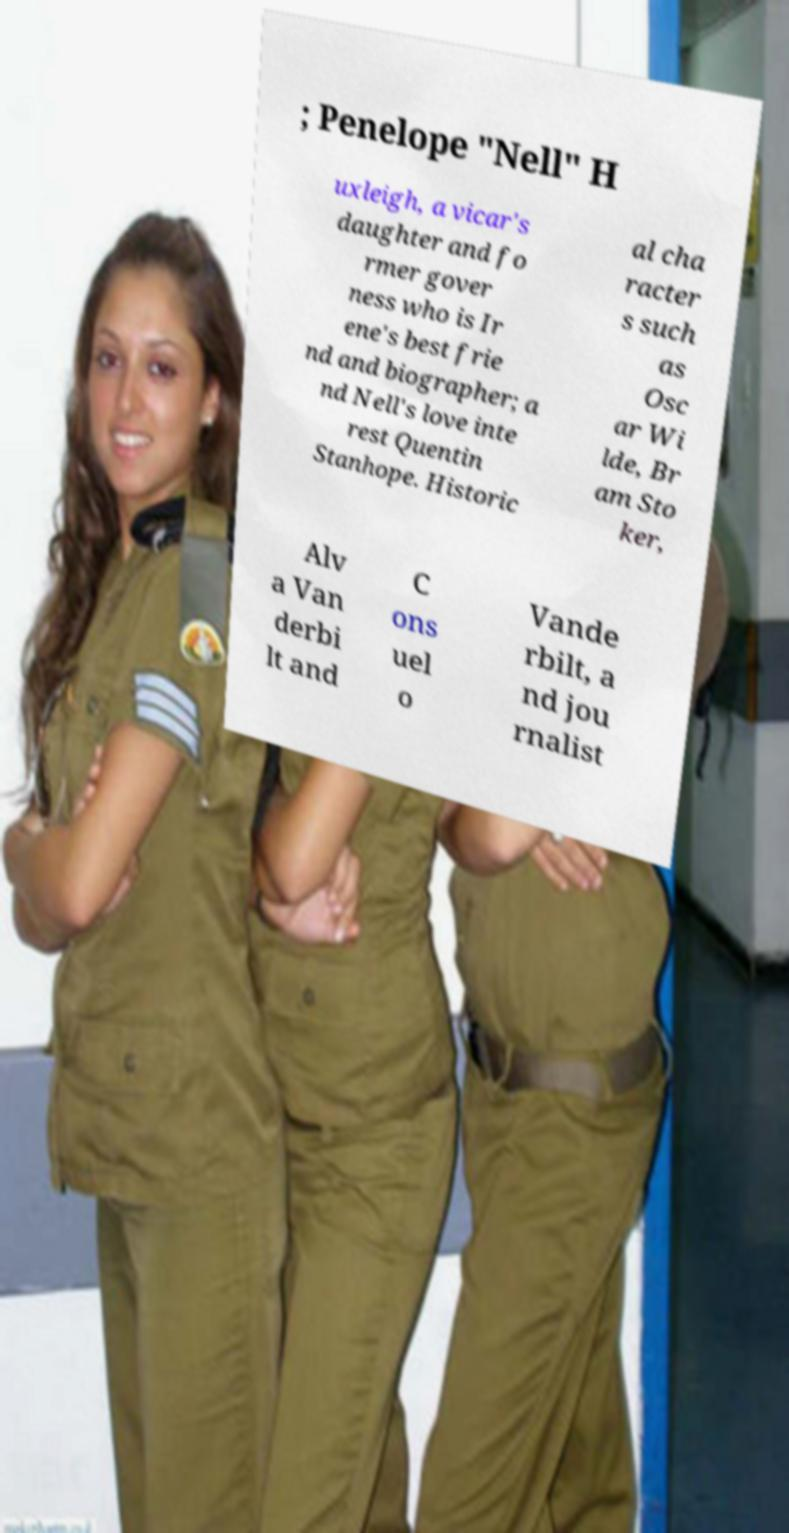Please identify and transcribe the text found in this image. ; Penelope "Nell" H uxleigh, a vicar's daughter and fo rmer gover ness who is Ir ene's best frie nd and biographer; a nd Nell's love inte rest Quentin Stanhope. Historic al cha racter s such as Osc ar Wi lde, Br am Sto ker, Alv a Van derbi lt and C ons uel o Vande rbilt, a nd jou rnalist 